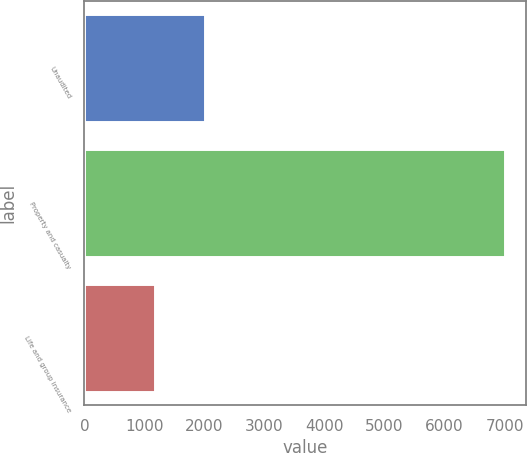Convert chart. <chart><loc_0><loc_0><loc_500><loc_500><bar_chart><fcel>Unaudited<fcel>Property and casualty<fcel>Life and group insurance<nl><fcel>2004<fcel>6998<fcel>1177<nl></chart> 